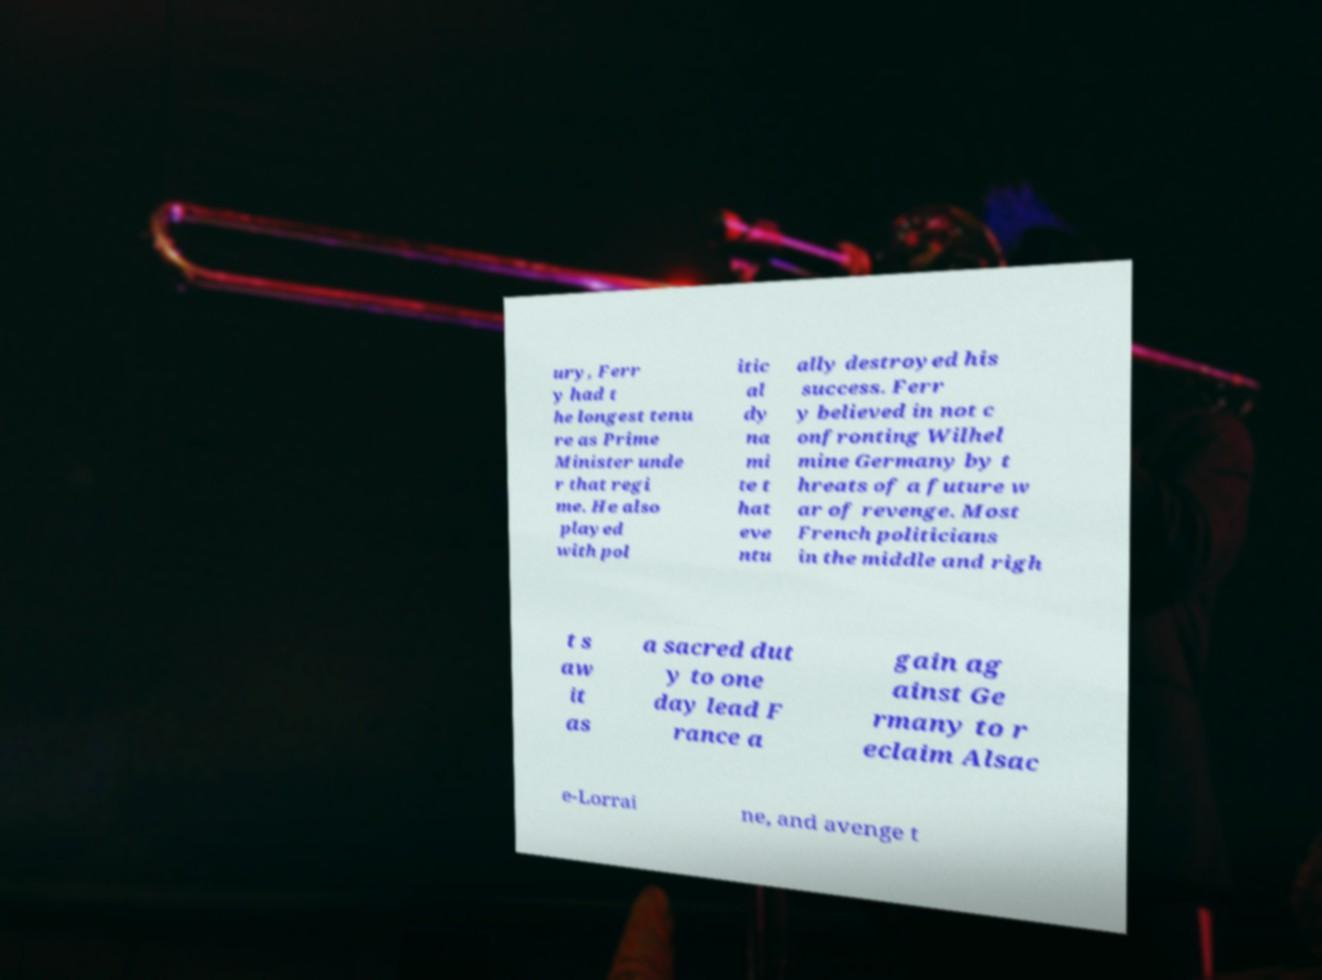There's text embedded in this image that I need extracted. Can you transcribe it verbatim? ury, Ferr y had t he longest tenu re as Prime Minister unde r that regi me. He also played with pol itic al dy na mi te t hat eve ntu ally destroyed his success. Ferr y believed in not c onfronting Wilhel mine Germany by t hreats of a future w ar of revenge. Most French politicians in the middle and righ t s aw it as a sacred dut y to one day lead F rance a gain ag ainst Ge rmany to r eclaim Alsac e-Lorrai ne, and avenge t 